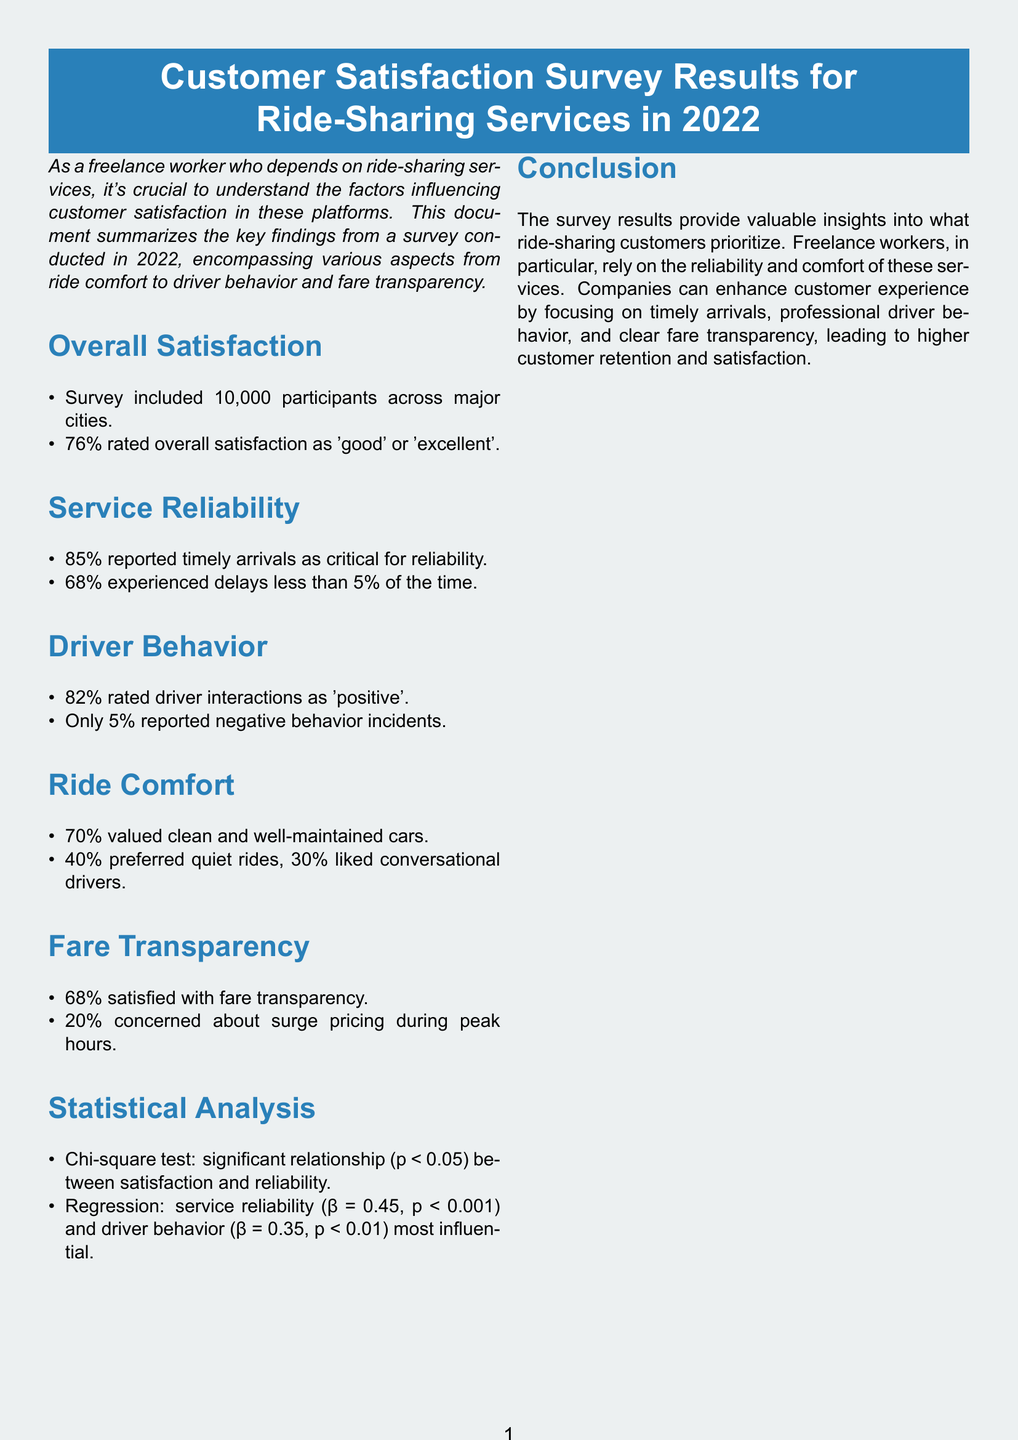What percentage of participants rated overall satisfaction as 'good' or 'excellent'? The document states that 76% of participants rated their overall satisfaction as 'good' or 'excellent'.
Answer: 76% What factor did 85% of respondents report as critical for reliability? The document highlights that 85% reported timely arrivals as critical for reliability.
Answer: Timely arrivals What percentage of respondents rated driver interactions as 'positive'? According to the document, 82% rated driver interactions as 'positive'.
Answer: 82% How many participants were included in the survey? The document indicates that the survey included 10,000 participants across major cities.
Answer: 10,000 What was the p-value that indicated a significant relationship between satisfaction and reliability? The document mentions a significant relationship with a p-value less than 0.05.
Answer: p < 0.05 Which two factors were found to be the most influential in the survey analysis? The document states that service reliability and driver behavior were the most influential factors.
Answer: Service reliability and driver behavior What percentage of respondents were concerned about surge pricing? The document reports that 20% of respondents were concerned about surge pricing during peak hours.
Answer: 20% What was the percentage of participants who experienced delays less than 5% of the time? The document notes that 68% experienced delays less than 5% of the time.
Answer: 68% How did the overall conclusion tie to the priorities of freelance workers? The conclusion emphasizes that freelance workers rely on the reliability and comfort of ride-sharing services.
Answer: Reliability and comfort 